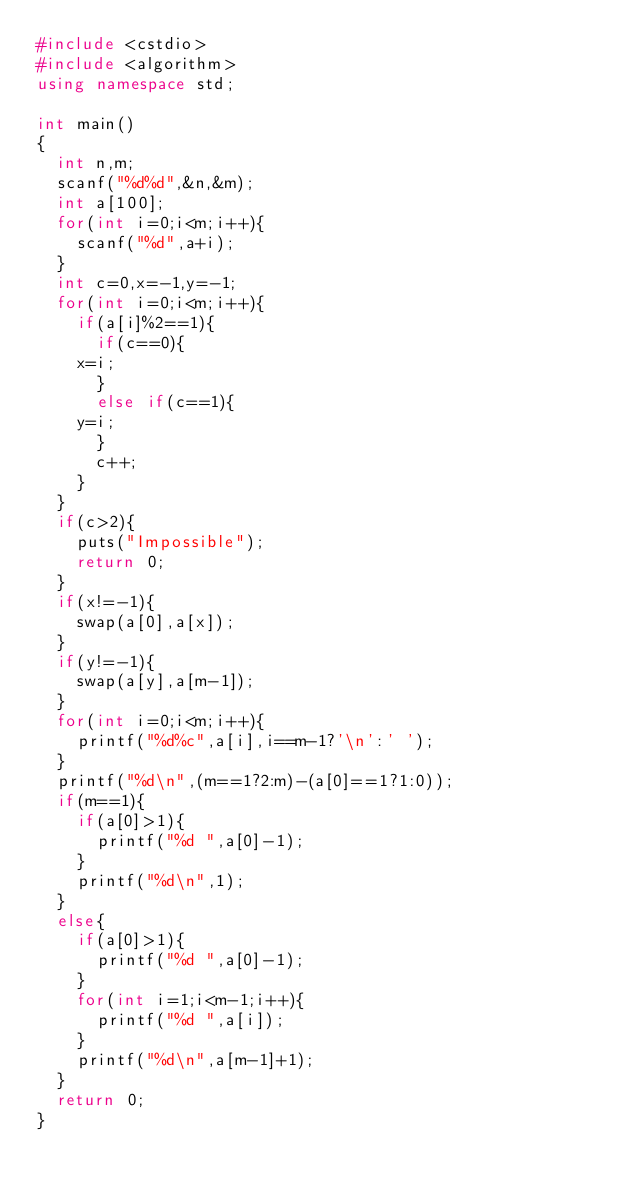Convert code to text. <code><loc_0><loc_0><loc_500><loc_500><_C++_>#include <cstdio>
#include <algorithm>
using namespace std;

int main()
{
  int n,m;
  scanf("%d%d",&n,&m);
  int a[100];
  for(int i=0;i<m;i++){
    scanf("%d",a+i);
  }
  int c=0,x=-1,y=-1;
  for(int i=0;i<m;i++){
    if(a[i]%2==1){
      if(c==0){
	x=i;
      }
      else if(c==1){
	y=i;
      }
      c++;
    }
  }
  if(c>2){
    puts("Impossible");
    return 0;
  }
  if(x!=-1){
    swap(a[0],a[x]);
  }
  if(y!=-1){
    swap(a[y],a[m-1]);
  }
  for(int i=0;i<m;i++){
    printf("%d%c",a[i],i==m-1?'\n':' ');
  }
  printf("%d\n",(m==1?2:m)-(a[0]==1?1:0));
  if(m==1){
    if(a[0]>1){
      printf("%d ",a[0]-1);
    }
    printf("%d\n",1);
  }
  else{
    if(a[0]>1){
      printf("%d ",a[0]-1);
    }
    for(int i=1;i<m-1;i++){
      printf("%d ",a[i]);
    }
    printf("%d\n",a[m-1]+1);
  }
  return 0;
}
</code> 